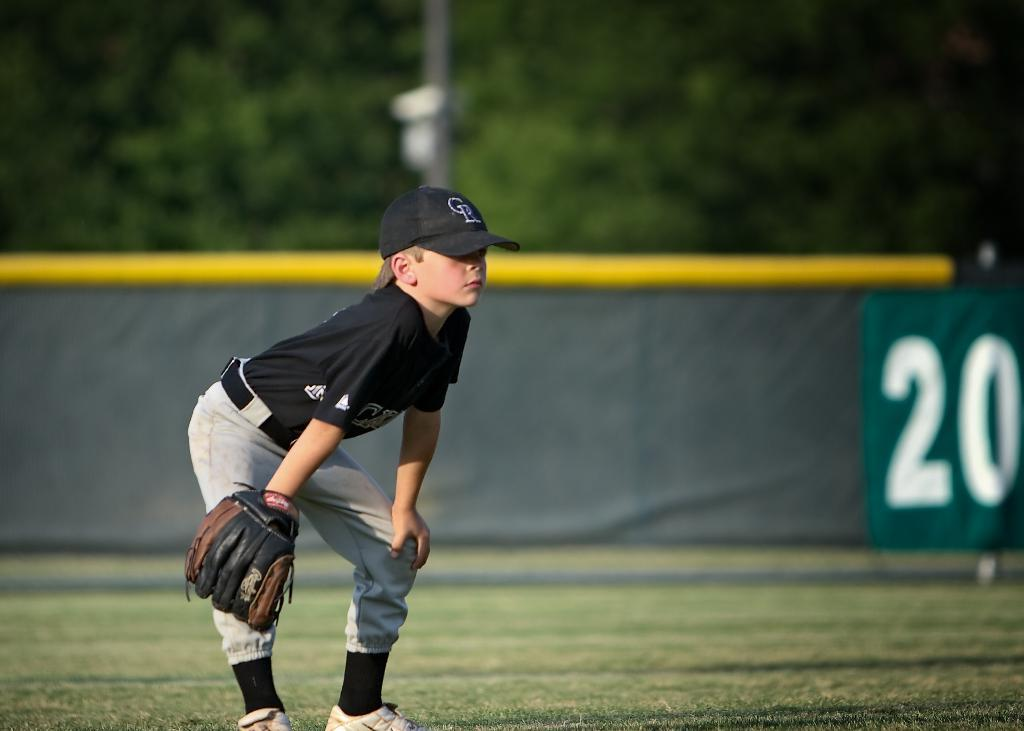<image>
Give a short and clear explanation of the subsequent image. Baseball player wearing a black jersey and a cap which says CR on it. 